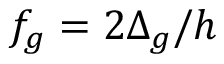Convert formula to latex. <formula><loc_0><loc_0><loc_500><loc_500>f _ { g } = 2 \Delta _ { g } / h</formula> 